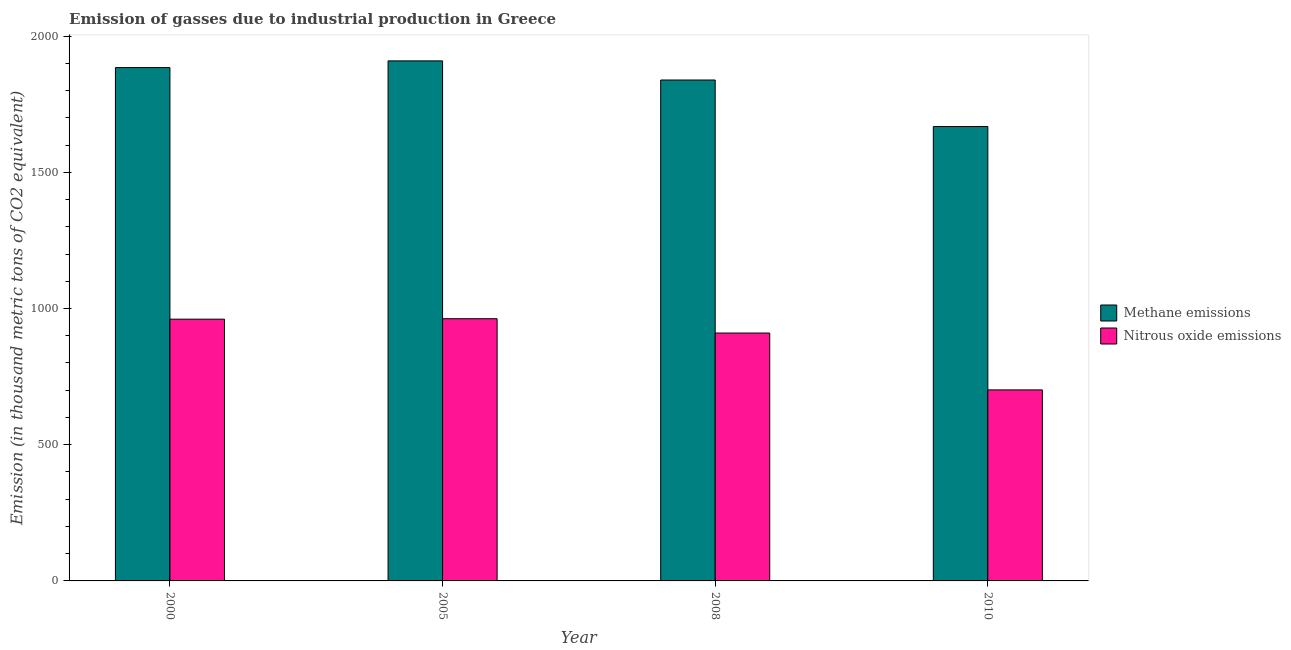How many groups of bars are there?
Provide a short and direct response. 4. Are the number of bars per tick equal to the number of legend labels?
Your response must be concise. Yes. How many bars are there on the 4th tick from the left?
Give a very brief answer. 2. How many bars are there on the 3rd tick from the right?
Offer a terse response. 2. What is the amount of methane emissions in 2008?
Provide a short and direct response. 1838.7. Across all years, what is the maximum amount of methane emissions?
Keep it short and to the point. 1908.9. Across all years, what is the minimum amount of methane emissions?
Your answer should be very brief. 1667.9. In which year was the amount of nitrous oxide emissions maximum?
Provide a succinct answer. 2005. In which year was the amount of methane emissions minimum?
Your answer should be compact. 2010. What is the total amount of nitrous oxide emissions in the graph?
Keep it short and to the point. 3534.4. What is the difference between the amount of methane emissions in 2000 and that in 2010?
Your answer should be compact. 216.4. What is the difference between the amount of nitrous oxide emissions in 2000 and the amount of methane emissions in 2008?
Your response must be concise. 50.9. What is the average amount of methane emissions per year?
Make the answer very short. 1824.95. In how many years, is the amount of methane emissions greater than 1500 thousand metric tons?
Ensure brevity in your answer.  4. What is the ratio of the amount of nitrous oxide emissions in 2005 to that in 2010?
Ensure brevity in your answer.  1.37. Is the amount of methane emissions in 2000 less than that in 2008?
Give a very brief answer. No. Is the difference between the amount of nitrous oxide emissions in 2005 and 2010 greater than the difference between the amount of methane emissions in 2005 and 2010?
Provide a short and direct response. No. What is the difference between the highest and the second highest amount of methane emissions?
Give a very brief answer. 24.6. What is the difference between the highest and the lowest amount of methane emissions?
Your answer should be compact. 241. Is the sum of the amount of nitrous oxide emissions in 2000 and 2010 greater than the maximum amount of methane emissions across all years?
Offer a terse response. Yes. What does the 2nd bar from the left in 2010 represents?
Provide a short and direct response. Nitrous oxide emissions. What does the 2nd bar from the right in 2008 represents?
Your answer should be compact. Methane emissions. How many bars are there?
Offer a terse response. 8. Are all the bars in the graph horizontal?
Provide a short and direct response. No. Does the graph contain any zero values?
Offer a terse response. No. How many legend labels are there?
Provide a short and direct response. 2. What is the title of the graph?
Ensure brevity in your answer.  Emission of gasses due to industrial production in Greece. What is the label or title of the Y-axis?
Offer a terse response. Emission (in thousand metric tons of CO2 equivalent). What is the Emission (in thousand metric tons of CO2 equivalent) of Methane emissions in 2000?
Your answer should be very brief. 1884.3. What is the Emission (in thousand metric tons of CO2 equivalent) of Nitrous oxide emissions in 2000?
Make the answer very short. 960.8. What is the Emission (in thousand metric tons of CO2 equivalent) in Methane emissions in 2005?
Offer a very short reply. 1908.9. What is the Emission (in thousand metric tons of CO2 equivalent) in Nitrous oxide emissions in 2005?
Keep it short and to the point. 962.5. What is the Emission (in thousand metric tons of CO2 equivalent) in Methane emissions in 2008?
Give a very brief answer. 1838.7. What is the Emission (in thousand metric tons of CO2 equivalent) in Nitrous oxide emissions in 2008?
Your answer should be compact. 909.9. What is the Emission (in thousand metric tons of CO2 equivalent) of Methane emissions in 2010?
Your answer should be very brief. 1667.9. What is the Emission (in thousand metric tons of CO2 equivalent) in Nitrous oxide emissions in 2010?
Your answer should be very brief. 701.2. Across all years, what is the maximum Emission (in thousand metric tons of CO2 equivalent) of Methane emissions?
Provide a succinct answer. 1908.9. Across all years, what is the maximum Emission (in thousand metric tons of CO2 equivalent) of Nitrous oxide emissions?
Your answer should be very brief. 962.5. Across all years, what is the minimum Emission (in thousand metric tons of CO2 equivalent) in Methane emissions?
Offer a very short reply. 1667.9. Across all years, what is the minimum Emission (in thousand metric tons of CO2 equivalent) in Nitrous oxide emissions?
Give a very brief answer. 701.2. What is the total Emission (in thousand metric tons of CO2 equivalent) of Methane emissions in the graph?
Offer a very short reply. 7299.8. What is the total Emission (in thousand metric tons of CO2 equivalent) in Nitrous oxide emissions in the graph?
Offer a very short reply. 3534.4. What is the difference between the Emission (in thousand metric tons of CO2 equivalent) in Methane emissions in 2000 and that in 2005?
Offer a terse response. -24.6. What is the difference between the Emission (in thousand metric tons of CO2 equivalent) in Methane emissions in 2000 and that in 2008?
Ensure brevity in your answer.  45.6. What is the difference between the Emission (in thousand metric tons of CO2 equivalent) of Nitrous oxide emissions in 2000 and that in 2008?
Offer a very short reply. 50.9. What is the difference between the Emission (in thousand metric tons of CO2 equivalent) in Methane emissions in 2000 and that in 2010?
Your answer should be compact. 216.4. What is the difference between the Emission (in thousand metric tons of CO2 equivalent) of Nitrous oxide emissions in 2000 and that in 2010?
Offer a terse response. 259.6. What is the difference between the Emission (in thousand metric tons of CO2 equivalent) in Methane emissions in 2005 and that in 2008?
Keep it short and to the point. 70.2. What is the difference between the Emission (in thousand metric tons of CO2 equivalent) of Nitrous oxide emissions in 2005 and that in 2008?
Provide a short and direct response. 52.6. What is the difference between the Emission (in thousand metric tons of CO2 equivalent) in Methane emissions in 2005 and that in 2010?
Keep it short and to the point. 241. What is the difference between the Emission (in thousand metric tons of CO2 equivalent) in Nitrous oxide emissions in 2005 and that in 2010?
Give a very brief answer. 261.3. What is the difference between the Emission (in thousand metric tons of CO2 equivalent) in Methane emissions in 2008 and that in 2010?
Keep it short and to the point. 170.8. What is the difference between the Emission (in thousand metric tons of CO2 equivalent) of Nitrous oxide emissions in 2008 and that in 2010?
Your answer should be compact. 208.7. What is the difference between the Emission (in thousand metric tons of CO2 equivalent) in Methane emissions in 2000 and the Emission (in thousand metric tons of CO2 equivalent) in Nitrous oxide emissions in 2005?
Provide a succinct answer. 921.8. What is the difference between the Emission (in thousand metric tons of CO2 equivalent) in Methane emissions in 2000 and the Emission (in thousand metric tons of CO2 equivalent) in Nitrous oxide emissions in 2008?
Offer a very short reply. 974.4. What is the difference between the Emission (in thousand metric tons of CO2 equivalent) of Methane emissions in 2000 and the Emission (in thousand metric tons of CO2 equivalent) of Nitrous oxide emissions in 2010?
Provide a succinct answer. 1183.1. What is the difference between the Emission (in thousand metric tons of CO2 equivalent) in Methane emissions in 2005 and the Emission (in thousand metric tons of CO2 equivalent) in Nitrous oxide emissions in 2008?
Offer a very short reply. 999. What is the difference between the Emission (in thousand metric tons of CO2 equivalent) in Methane emissions in 2005 and the Emission (in thousand metric tons of CO2 equivalent) in Nitrous oxide emissions in 2010?
Give a very brief answer. 1207.7. What is the difference between the Emission (in thousand metric tons of CO2 equivalent) of Methane emissions in 2008 and the Emission (in thousand metric tons of CO2 equivalent) of Nitrous oxide emissions in 2010?
Your answer should be very brief. 1137.5. What is the average Emission (in thousand metric tons of CO2 equivalent) in Methane emissions per year?
Your answer should be compact. 1824.95. What is the average Emission (in thousand metric tons of CO2 equivalent) in Nitrous oxide emissions per year?
Your answer should be compact. 883.6. In the year 2000, what is the difference between the Emission (in thousand metric tons of CO2 equivalent) in Methane emissions and Emission (in thousand metric tons of CO2 equivalent) in Nitrous oxide emissions?
Ensure brevity in your answer.  923.5. In the year 2005, what is the difference between the Emission (in thousand metric tons of CO2 equivalent) in Methane emissions and Emission (in thousand metric tons of CO2 equivalent) in Nitrous oxide emissions?
Your answer should be very brief. 946.4. In the year 2008, what is the difference between the Emission (in thousand metric tons of CO2 equivalent) in Methane emissions and Emission (in thousand metric tons of CO2 equivalent) in Nitrous oxide emissions?
Offer a terse response. 928.8. In the year 2010, what is the difference between the Emission (in thousand metric tons of CO2 equivalent) in Methane emissions and Emission (in thousand metric tons of CO2 equivalent) in Nitrous oxide emissions?
Offer a terse response. 966.7. What is the ratio of the Emission (in thousand metric tons of CO2 equivalent) in Methane emissions in 2000 to that in 2005?
Provide a succinct answer. 0.99. What is the ratio of the Emission (in thousand metric tons of CO2 equivalent) of Methane emissions in 2000 to that in 2008?
Provide a succinct answer. 1.02. What is the ratio of the Emission (in thousand metric tons of CO2 equivalent) of Nitrous oxide emissions in 2000 to that in 2008?
Your answer should be compact. 1.06. What is the ratio of the Emission (in thousand metric tons of CO2 equivalent) of Methane emissions in 2000 to that in 2010?
Provide a succinct answer. 1.13. What is the ratio of the Emission (in thousand metric tons of CO2 equivalent) of Nitrous oxide emissions in 2000 to that in 2010?
Give a very brief answer. 1.37. What is the ratio of the Emission (in thousand metric tons of CO2 equivalent) in Methane emissions in 2005 to that in 2008?
Your answer should be very brief. 1.04. What is the ratio of the Emission (in thousand metric tons of CO2 equivalent) in Nitrous oxide emissions in 2005 to that in 2008?
Your answer should be very brief. 1.06. What is the ratio of the Emission (in thousand metric tons of CO2 equivalent) of Methane emissions in 2005 to that in 2010?
Offer a very short reply. 1.14. What is the ratio of the Emission (in thousand metric tons of CO2 equivalent) in Nitrous oxide emissions in 2005 to that in 2010?
Provide a short and direct response. 1.37. What is the ratio of the Emission (in thousand metric tons of CO2 equivalent) in Methane emissions in 2008 to that in 2010?
Provide a short and direct response. 1.1. What is the ratio of the Emission (in thousand metric tons of CO2 equivalent) in Nitrous oxide emissions in 2008 to that in 2010?
Offer a terse response. 1.3. What is the difference between the highest and the second highest Emission (in thousand metric tons of CO2 equivalent) in Methane emissions?
Your answer should be compact. 24.6. What is the difference between the highest and the lowest Emission (in thousand metric tons of CO2 equivalent) of Methane emissions?
Your response must be concise. 241. What is the difference between the highest and the lowest Emission (in thousand metric tons of CO2 equivalent) in Nitrous oxide emissions?
Provide a short and direct response. 261.3. 